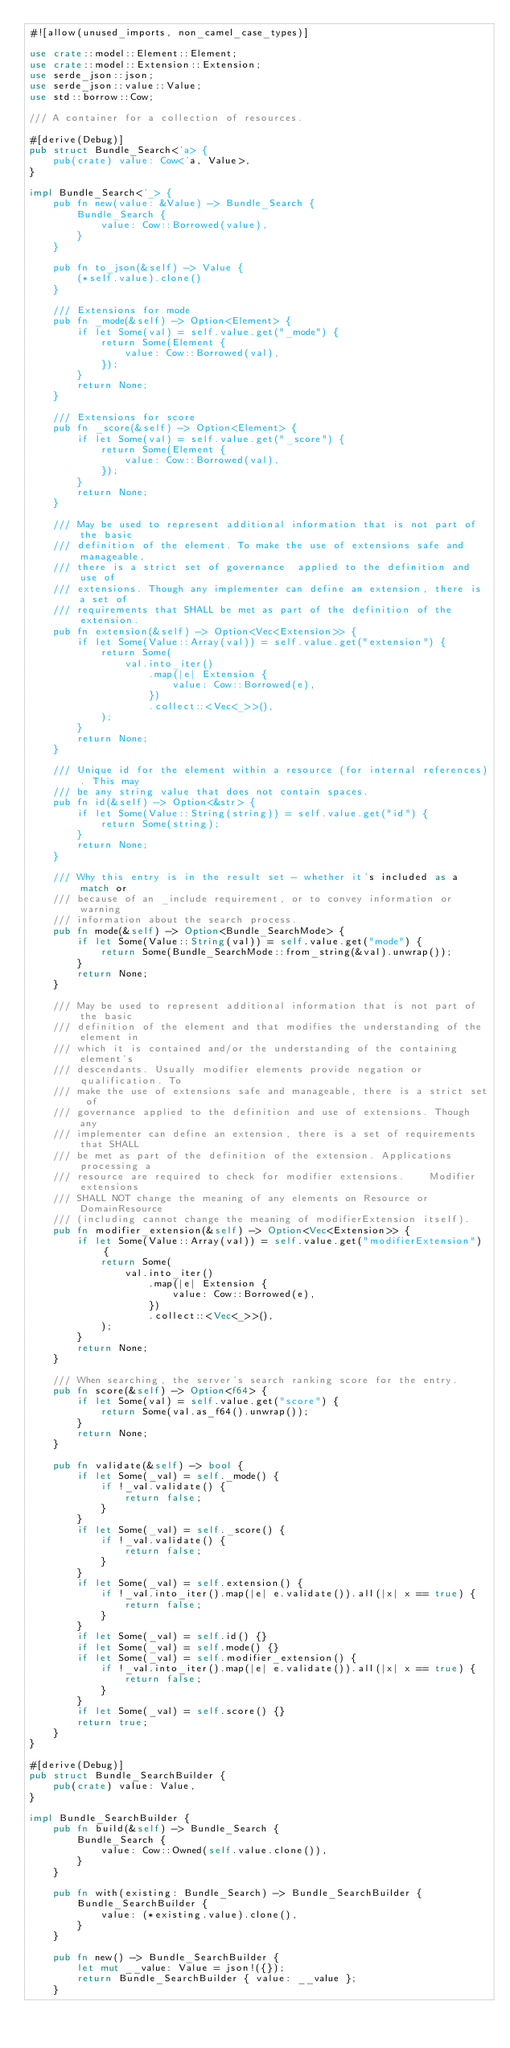Convert code to text. <code><loc_0><loc_0><loc_500><loc_500><_Rust_>#![allow(unused_imports, non_camel_case_types)]

use crate::model::Element::Element;
use crate::model::Extension::Extension;
use serde_json::json;
use serde_json::value::Value;
use std::borrow::Cow;

/// A container for a collection of resources.

#[derive(Debug)]
pub struct Bundle_Search<'a> {
    pub(crate) value: Cow<'a, Value>,
}

impl Bundle_Search<'_> {
    pub fn new(value: &Value) -> Bundle_Search {
        Bundle_Search {
            value: Cow::Borrowed(value),
        }
    }

    pub fn to_json(&self) -> Value {
        (*self.value).clone()
    }

    /// Extensions for mode
    pub fn _mode(&self) -> Option<Element> {
        if let Some(val) = self.value.get("_mode") {
            return Some(Element {
                value: Cow::Borrowed(val),
            });
        }
        return None;
    }

    /// Extensions for score
    pub fn _score(&self) -> Option<Element> {
        if let Some(val) = self.value.get("_score") {
            return Some(Element {
                value: Cow::Borrowed(val),
            });
        }
        return None;
    }

    /// May be used to represent additional information that is not part of the basic
    /// definition of the element. To make the use of extensions safe and manageable,
    /// there is a strict set of governance  applied to the definition and use of
    /// extensions. Though any implementer can define an extension, there is a set of
    /// requirements that SHALL be met as part of the definition of the extension.
    pub fn extension(&self) -> Option<Vec<Extension>> {
        if let Some(Value::Array(val)) = self.value.get("extension") {
            return Some(
                val.into_iter()
                    .map(|e| Extension {
                        value: Cow::Borrowed(e),
                    })
                    .collect::<Vec<_>>(),
            );
        }
        return None;
    }

    /// Unique id for the element within a resource (for internal references). This may
    /// be any string value that does not contain spaces.
    pub fn id(&self) -> Option<&str> {
        if let Some(Value::String(string)) = self.value.get("id") {
            return Some(string);
        }
        return None;
    }

    /// Why this entry is in the result set - whether it's included as a match or
    /// because of an _include requirement, or to convey information or warning
    /// information about the search process.
    pub fn mode(&self) -> Option<Bundle_SearchMode> {
        if let Some(Value::String(val)) = self.value.get("mode") {
            return Some(Bundle_SearchMode::from_string(&val).unwrap());
        }
        return None;
    }

    /// May be used to represent additional information that is not part of the basic
    /// definition of the element and that modifies the understanding of the element in
    /// which it is contained and/or the understanding of the containing element's
    /// descendants. Usually modifier elements provide negation or qualification. To
    /// make the use of extensions safe and manageable, there is a strict set of
    /// governance applied to the definition and use of extensions. Though any
    /// implementer can define an extension, there is a set of requirements that SHALL
    /// be met as part of the definition of the extension. Applications processing a
    /// resource are required to check for modifier extensions.    Modifier extensions
    /// SHALL NOT change the meaning of any elements on Resource or DomainResource
    /// (including cannot change the meaning of modifierExtension itself).
    pub fn modifier_extension(&self) -> Option<Vec<Extension>> {
        if let Some(Value::Array(val)) = self.value.get("modifierExtension") {
            return Some(
                val.into_iter()
                    .map(|e| Extension {
                        value: Cow::Borrowed(e),
                    })
                    .collect::<Vec<_>>(),
            );
        }
        return None;
    }

    /// When searching, the server's search ranking score for the entry.
    pub fn score(&self) -> Option<f64> {
        if let Some(val) = self.value.get("score") {
            return Some(val.as_f64().unwrap());
        }
        return None;
    }

    pub fn validate(&self) -> bool {
        if let Some(_val) = self._mode() {
            if !_val.validate() {
                return false;
            }
        }
        if let Some(_val) = self._score() {
            if !_val.validate() {
                return false;
            }
        }
        if let Some(_val) = self.extension() {
            if !_val.into_iter().map(|e| e.validate()).all(|x| x == true) {
                return false;
            }
        }
        if let Some(_val) = self.id() {}
        if let Some(_val) = self.mode() {}
        if let Some(_val) = self.modifier_extension() {
            if !_val.into_iter().map(|e| e.validate()).all(|x| x == true) {
                return false;
            }
        }
        if let Some(_val) = self.score() {}
        return true;
    }
}

#[derive(Debug)]
pub struct Bundle_SearchBuilder {
    pub(crate) value: Value,
}

impl Bundle_SearchBuilder {
    pub fn build(&self) -> Bundle_Search {
        Bundle_Search {
            value: Cow::Owned(self.value.clone()),
        }
    }

    pub fn with(existing: Bundle_Search) -> Bundle_SearchBuilder {
        Bundle_SearchBuilder {
            value: (*existing.value).clone(),
        }
    }

    pub fn new() -> Bundle_SearchBuilder {
        let mut __value: Value = json!({});
        return Bundle_SearchBuilder { value: __value };
    }
</code> 